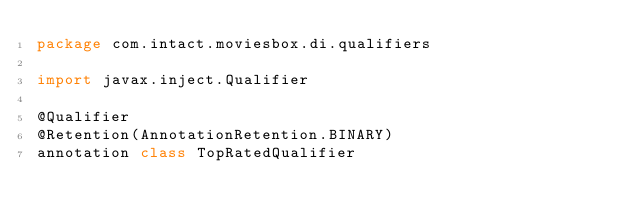<code> <loc_0><loc_0><loc_500><loc_500><_Kotlin_>package com.intact.moviesbox.di.qualifiers

import javax.inject.Qualifier

@Qualifier
@Retention(AnnotationRetention.BINARY)
annotation class TopRatedQualifier</code> 